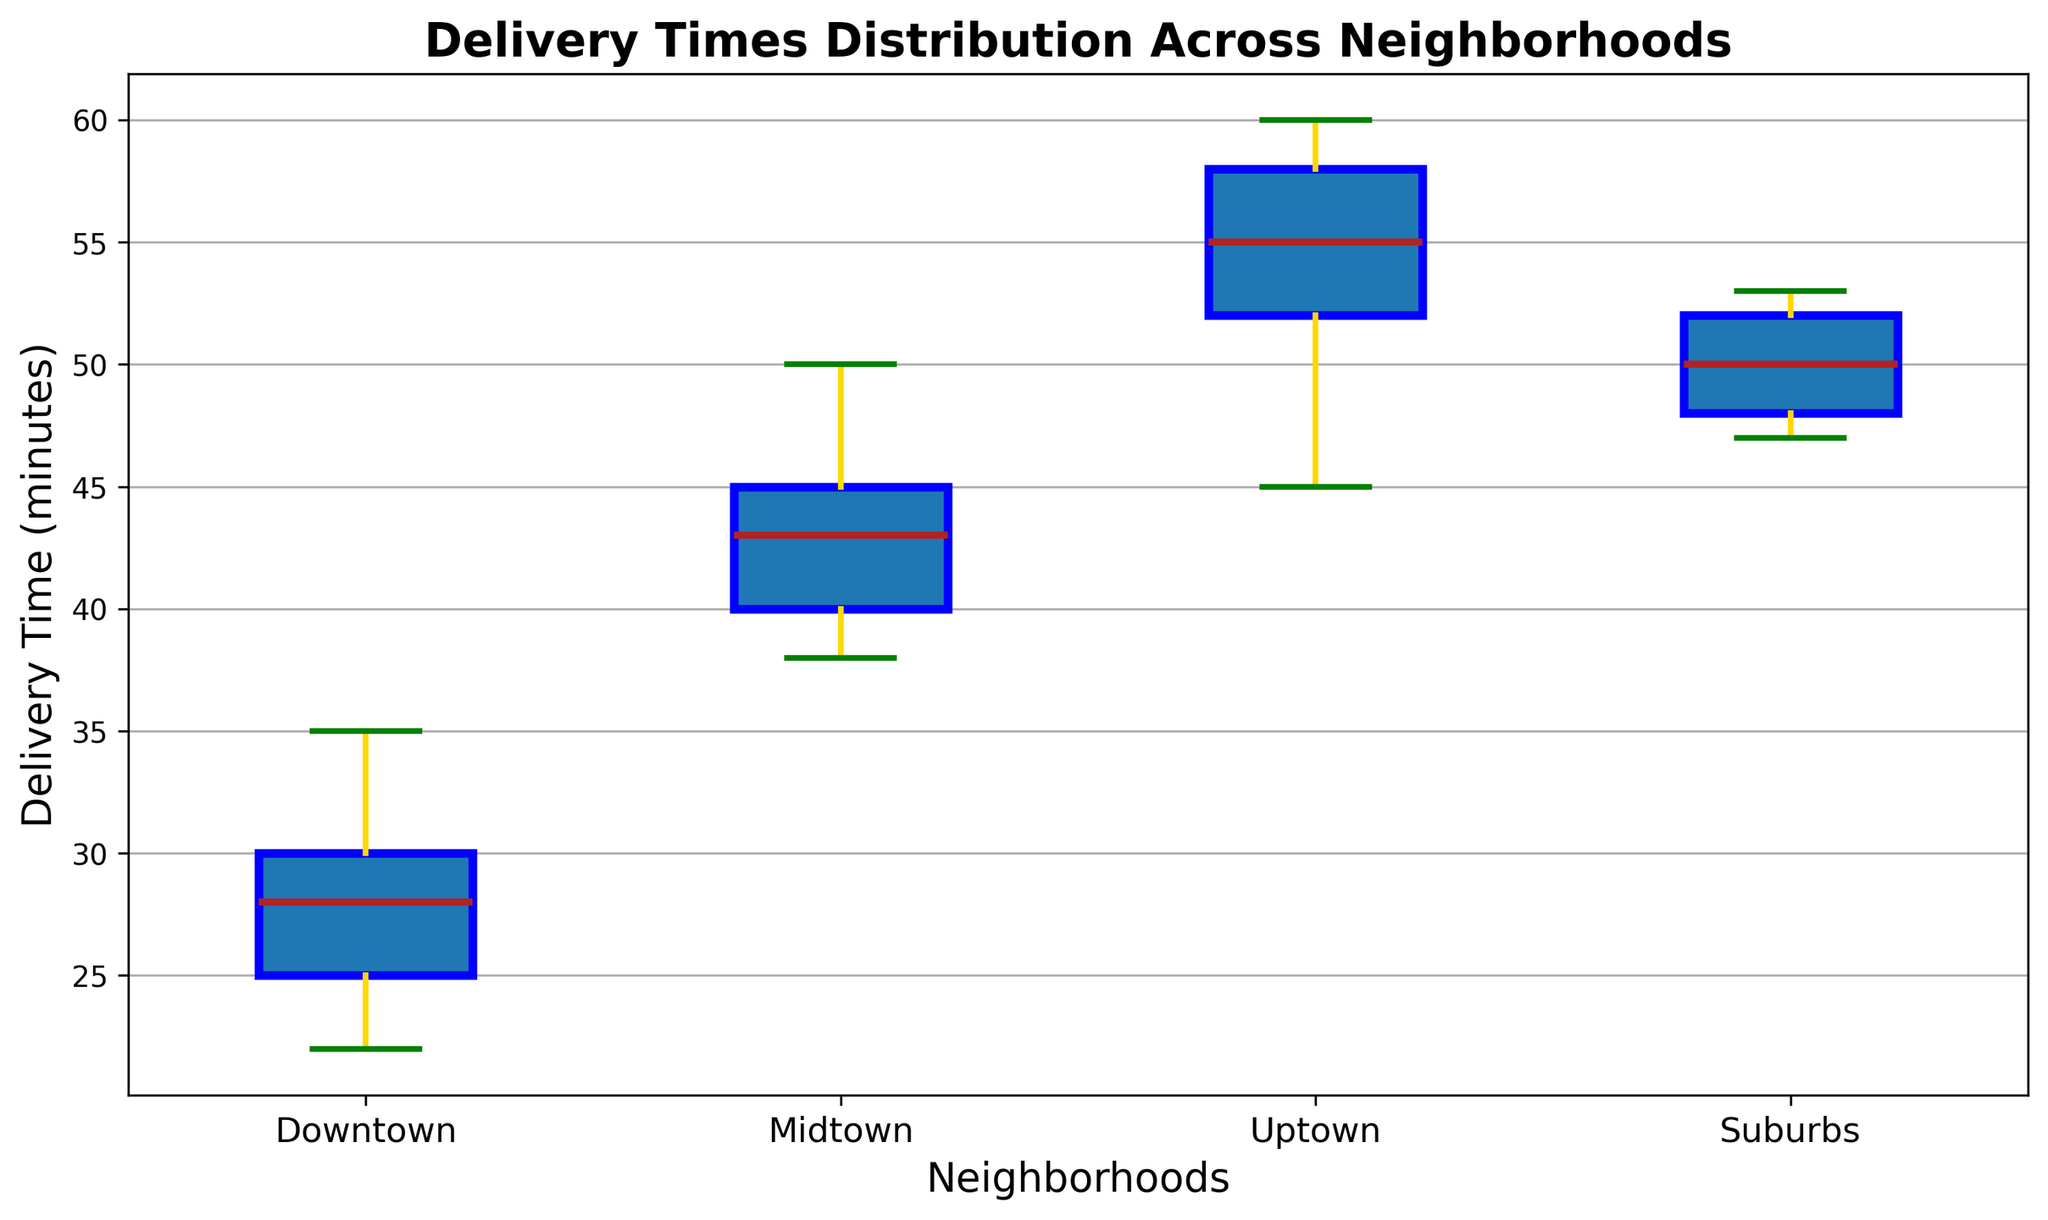Which neighborhood has the shortest median delivery time? To determine the neighborhood with the shortest median delivery time, look at the central line in each box for all neighborhoods and compare which is the lowest.
Answer: Downtown Which neighborhood has the widest range of delivery times? The range is determined by the whiskers extending from the box edges. Compare the spread of the whiskers for each neighborhood. The neighborhood with the longest distance between the top and bottom whiskers has the widest range.
Answer: Uptown Which neighborhoods have overlapping interquartile ranges (IQRs)? The IQR is represented by the box. Look for neighborhoods where the boxes overlap horizontally.
Answer: Midtown and Uptown How does the median delivery time in Suburbs compare to Downtown? Locate the median line in the boxes for both Suburbs and Downtown and compare their vertical positions.
Answer: Suburbs has a higher median What is the difference between the maximum delivery times in Midtown and Uptown? Look at the top whisker of both Midtown and Uptown to find their maximum values and subtract Midtown’s maximum from Uptown’s maximum.
Answer: 10 minutes In which neighborhood is the delivery time distribution most skewed? Skewness can be visualized by comparing the lengths of the whiskers and the position of the median within the box. A visibly asymmetric box-whisker structure indicates skewness.
Answer: Uptown What is notable about the whiskers in the Downtown? Compare the lengths of the whiskers in Downtown. If they are shorter compared to others, it's noteworthy for having less variability in extreme values.
Answer: Short whiskers, less variability Which neighborhoods have outliers in delivery times? Outliers are represented by individual points outside of the whiskers. Identify neighborhoods that have these points.
Answer: No outliers What do the box colors and various line attributes (median, whiskers, caps) signify visually? Identify what each component visually represents in a box plot: the boxes signify IQR, the central line signifies the median, whiskers denote minimum and maximum, caps limit the whisker extension, and dots represent outliers.
Answer: Box: IQR, Median: central line, Whiskers: data range, Caps: whisker limits, Dots: outliers 